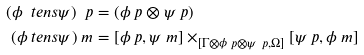Convert formula to latex. <formula><loc_0><loc_0><loc_500><loc_500>( \phi \ t e n s \psi ) \ p & = ( \phi \ p \otimes \psi \ p ) \\ ( \phi \ t e n s \psi ) \ m & = [ \phi \ p , \psi \ m ] \times _ { [ \Gamma \otimes \phi \ p \otimes \psi \ p , \Omega ] } [ \psi \ p , \phi \ m ]</formula> 